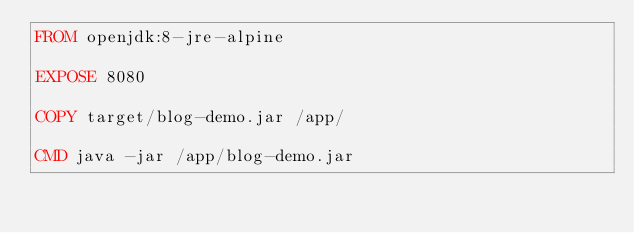Convert code to text. <code><loc_0><loc_0><loc_500><loc_500><_Dockerfile_>FROM openjdk:8-jre-alpine

EXPOSE 8080

COPY target/blog-demo.jar /app/

CMD java -jar /app/blog-demo.jar </code> 